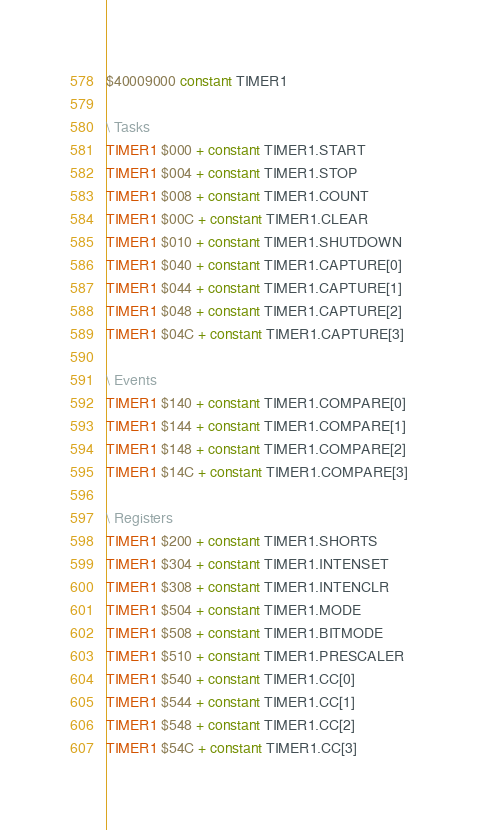<code> <loc_0><loc_0><loc_500><loc_500><_Forth_>$40009000 constant TIMER1

\ Tasks
TIMER1 $000 + constant TIMER1.START
TIMER1 $004 + constant TIMER1.STOP
TIMER1 $008 + constant TIMER1.COUNT
TIMER1 $00C + constant TIMER1.CLEAR
TIMER1 $010 + constant TIMER1.SHUTDOWN
TIMER1 $040 + constant TIMER1.CAPTURE[0]
TIMER1 $044 + constant TIMER1.CAPTURE[1]
TIMER1 $048 + constant TIMER1.CAPTURE[2]
TIMER1 $04C + constant TIMER1.CAPTURE[3]

\ Events
TIMER1 $140 + constant TIMER1.COMPARE[0]
TIMER1 $144 + constant TIMER1.COMPARE[1]
TIMER1 $148 + constant TIMER1.COMPARE[2]
TIMER1 $14C + constant TIMER1.COMPARE[3]

\ Registers
TIMER1 $200 + constant TIMER1.SHORTS
TIMER1 $304 + constant TIMER1.INTENSET
TIMER1 $308 + constant TIMER1.INTENCLR
TIMER1 $504 + constant TIMER1.MODE
TIMER1 $508 + constant TIMER1.BITMODE
TIMER1 $510 + constant TIMER1.PRESCALER
TIMER1 $540 + constant TIMER1.CC[0]
TIMER1 $544 + constant TIMER1.CC[1]
TIMER1 $548 + constant TIMER1.CC[2]
TIMER1 $54C + constant TIMER1.CC[3]
</code> 